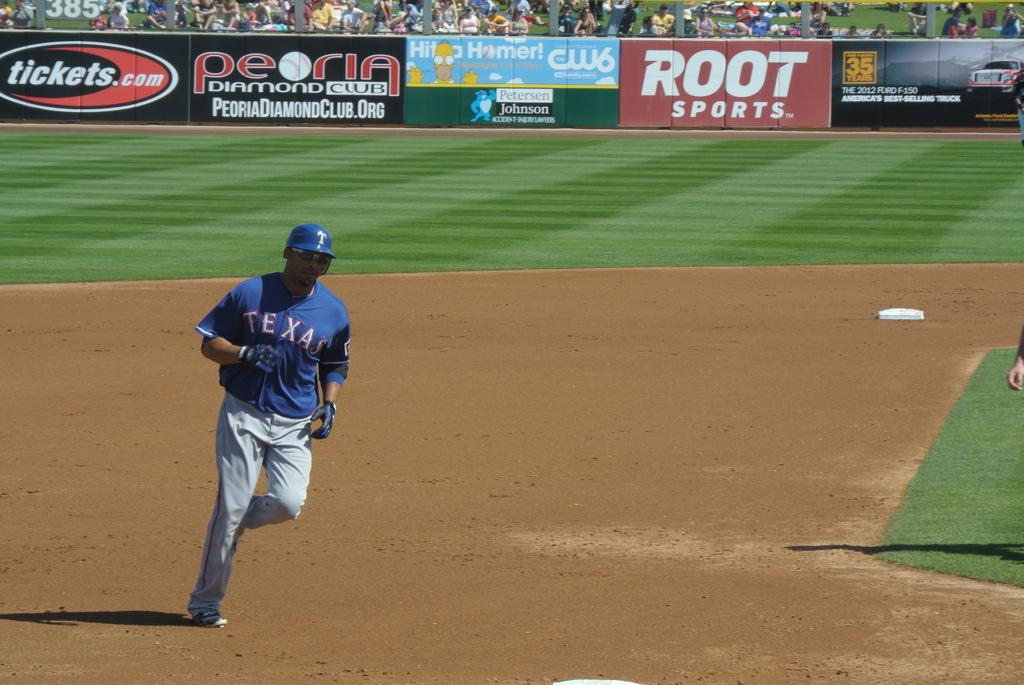<image>
Write a terse but informative summary of the picture. A man in a Texas baseball uniform runs to third base. 